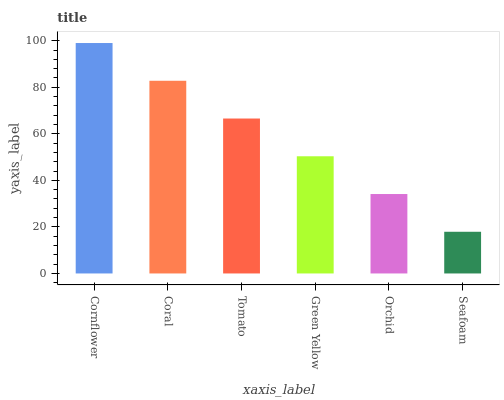Is Seafoam the minimum?
Answer yes or no. Yes. Is Cornflower the maximum?
Answer yes or no. Yes. Is Coral the minimum?
Answer yes or no. No. Is Coral the maximum?
Answer yes or no. No. Is Cornflower greater than Coral?
Answer yes or no. Yes. Is Coral less than Cornflower?
Answer yes or no. Yes. Is Coral greater than Cornflower?
Answer yes or no. No. Is Cornflower less than Coral?
Answer yes or no. No. Is Tomato the high median?
Answer yes or no. Yes. Is Green Yellow the low median?
Answer yes or no. Yes. Is Seafoam the high median?
Answer yes or no. No. Is Seafoam the low median?
Answer yes or no. No. 